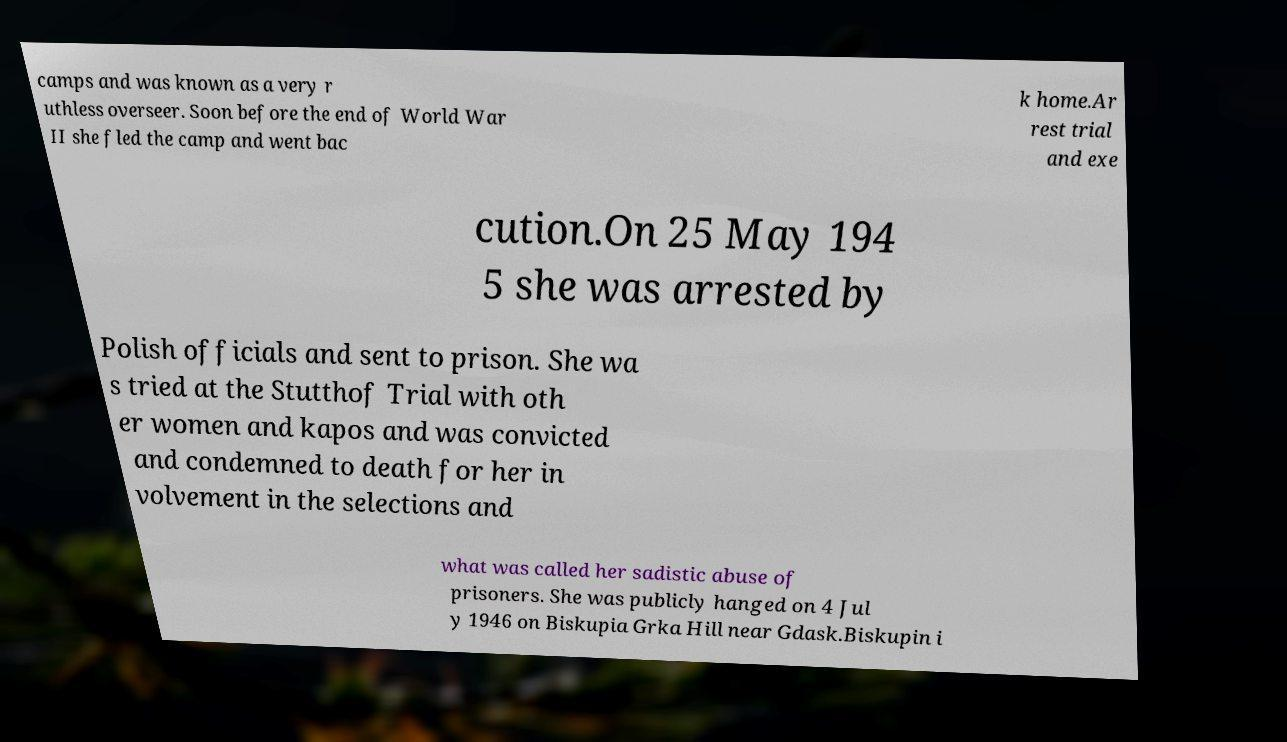There's text embedded in this image that I need extracted. Can you transcribe it verbatim? camps and was known as a very r uthless overseer. Soon before the end of World War II she fled the camp and went bac k home.Ar rest trial and exe cution.On 25 May 194 5 she was arrested by Polish officials and sent to prison. She wa s tried at the Stutthof Trial with oth er women and kapos and was convicted and condemned to death for her in volvement in the selections and what was called her sadistic abuse of prisoners. She was publicly hanged on 4 Jul y 1946 on Biskupia Grka Hill near Gdask.Biskupin i 